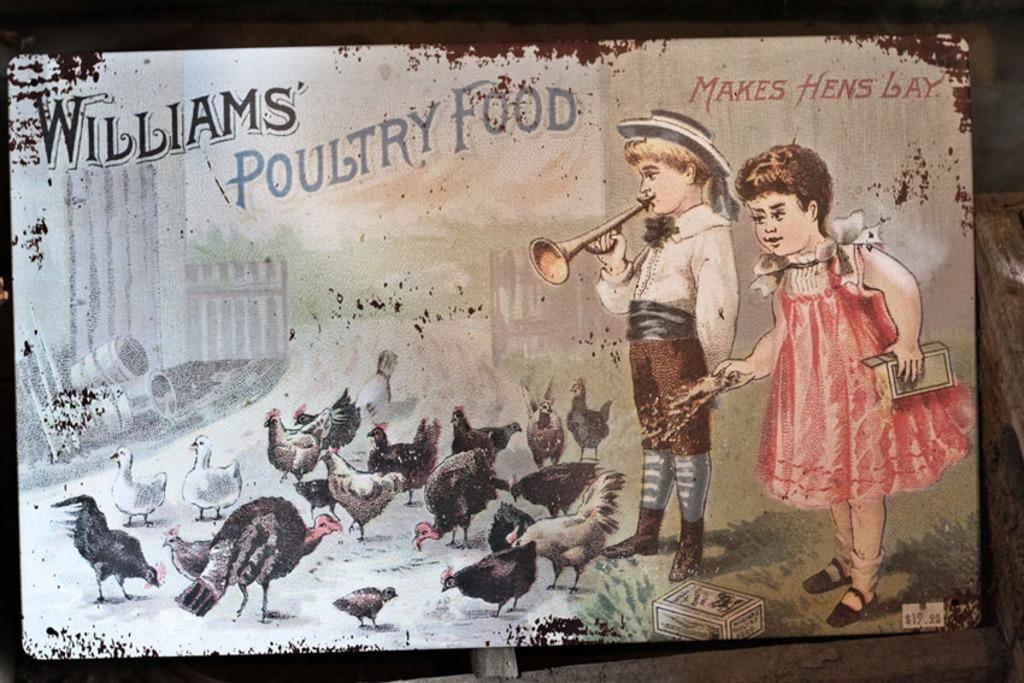In one or two sentences, can you explain what this image depicts? In this image I can see a board with some painting on it. 